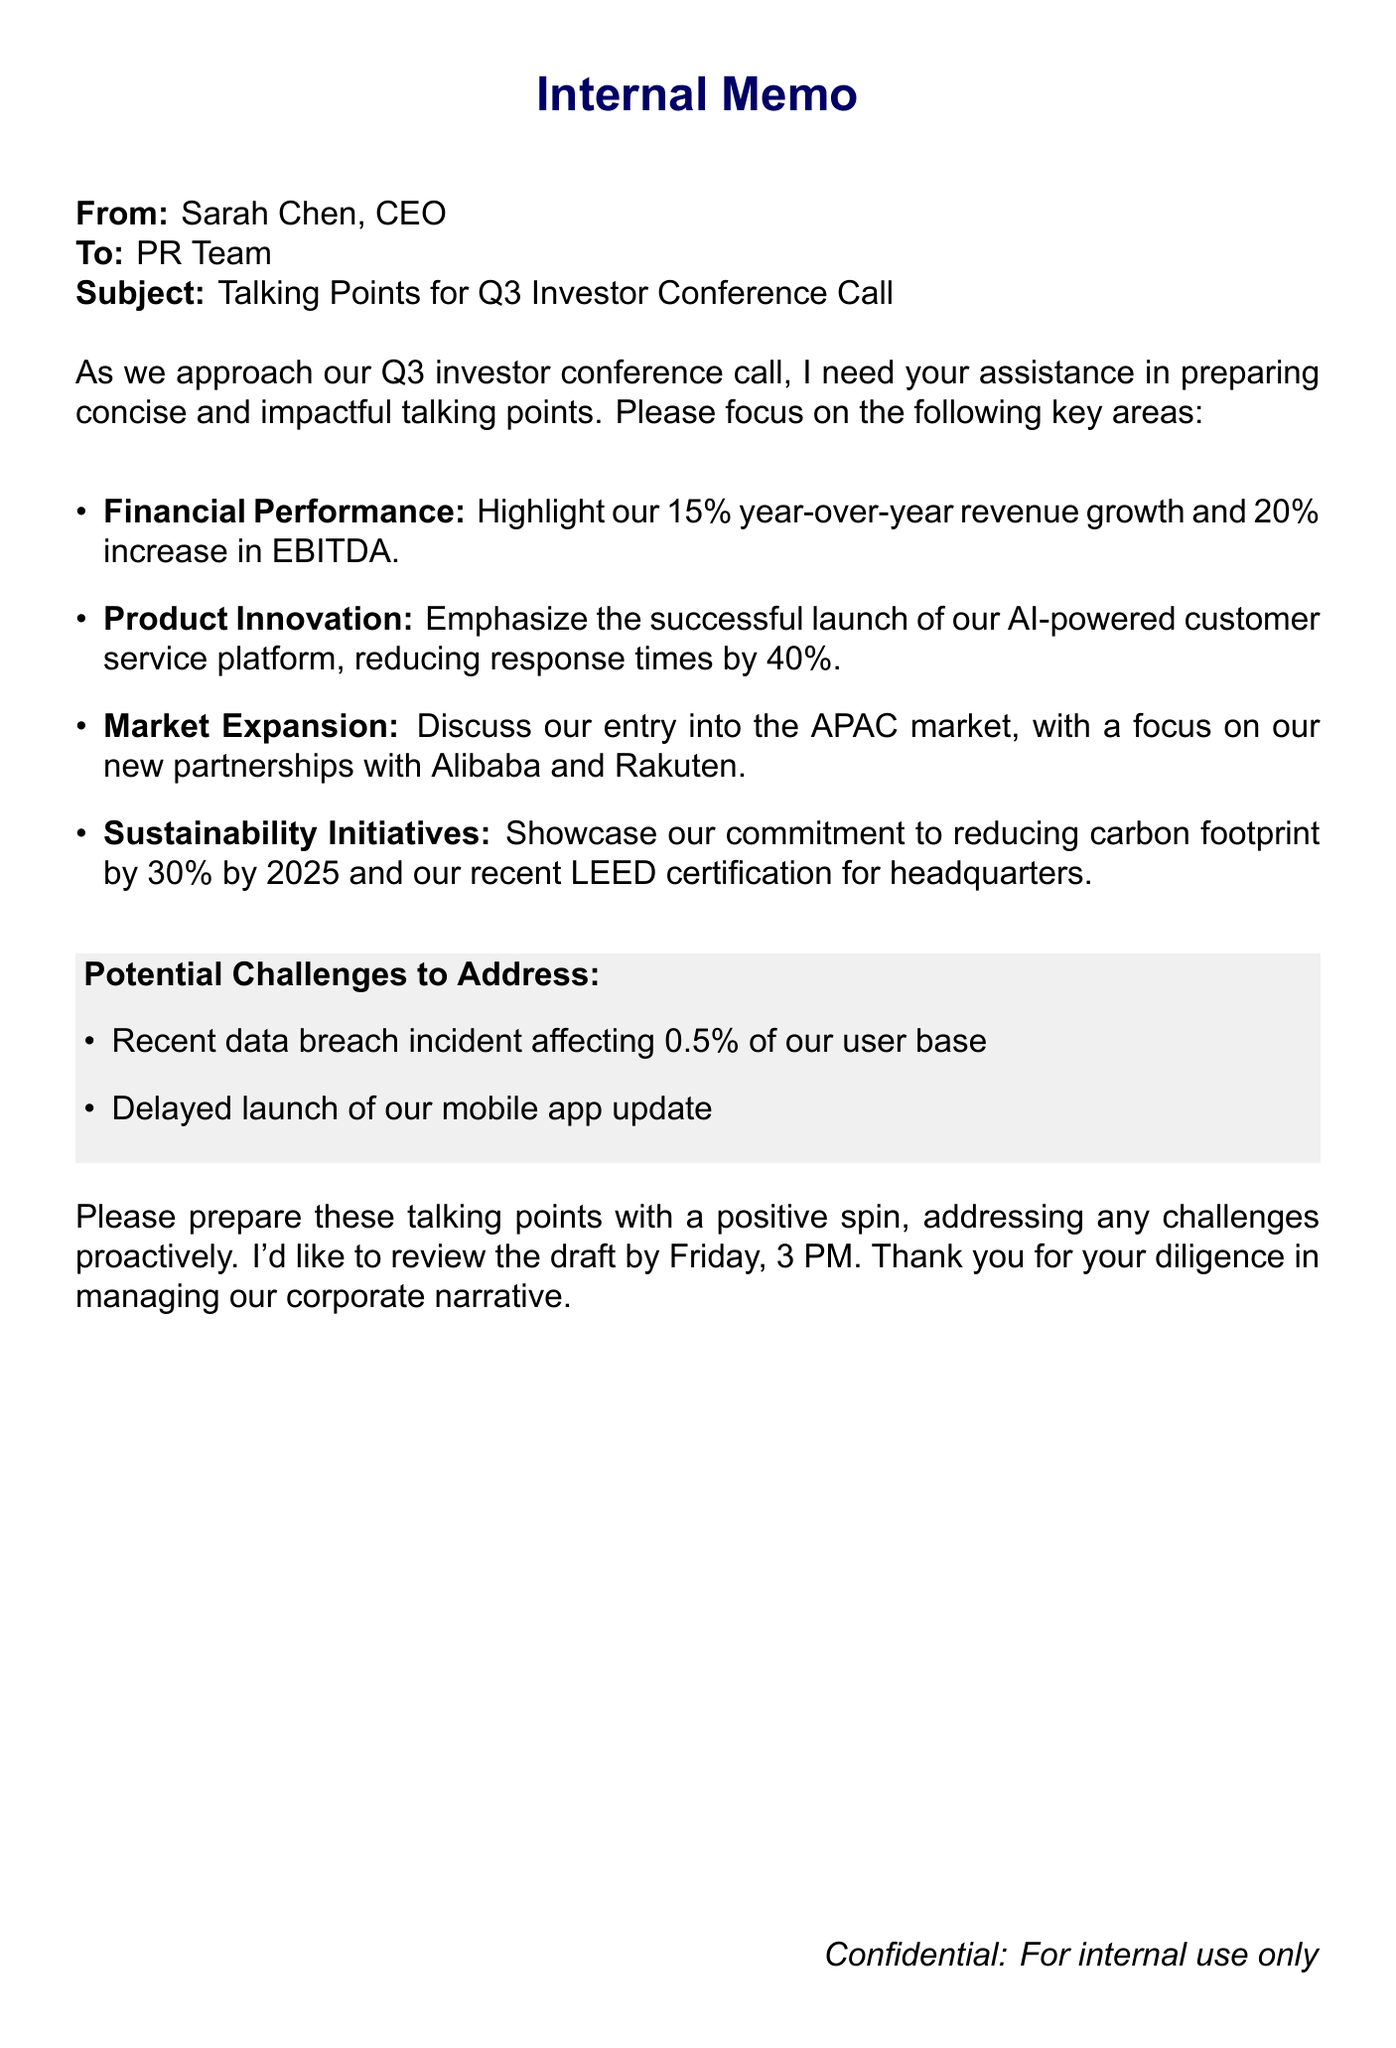What is the year-over-year revenue growth? The document states that the year-over-year revenue growth is 15%.
Answer: 15% What is the percentage increase in EBITDA? According to the email, the increase in EBITDA is 20%.
Answer: 20% Which two companies are mentioned in relation to market expansion? The email discusses partnerships with Alibaba and Rakuten regarding market expansion.
Answer: Alibaba and Rakuten What is the target year for reducing the carbon footprint by 30%? The document mentions the year 2025 as the target for reducing the carbon footprint.
Answer: 2025 What incident affected 0.5% of the user base? A recent data breach incident is mentioned as affecting 0.5% of the user base.
Answer: Data breach incident What is the deadline for the draft review? The CEO has set the review deadline for Friday at 3 PM.
Answer: Friday, 3 PM What initiative is showcased in the email regarding sustainability? The document highlights the commitment to reducing carbon footprint and attaining LEED certification.
Answer: Reducing carbon footprint and LEED certification What aspect of product innovation is emphasized? The focus is on the successful launch of the AI-powered customer service platform.
Answer: AI-powered customer service platform 